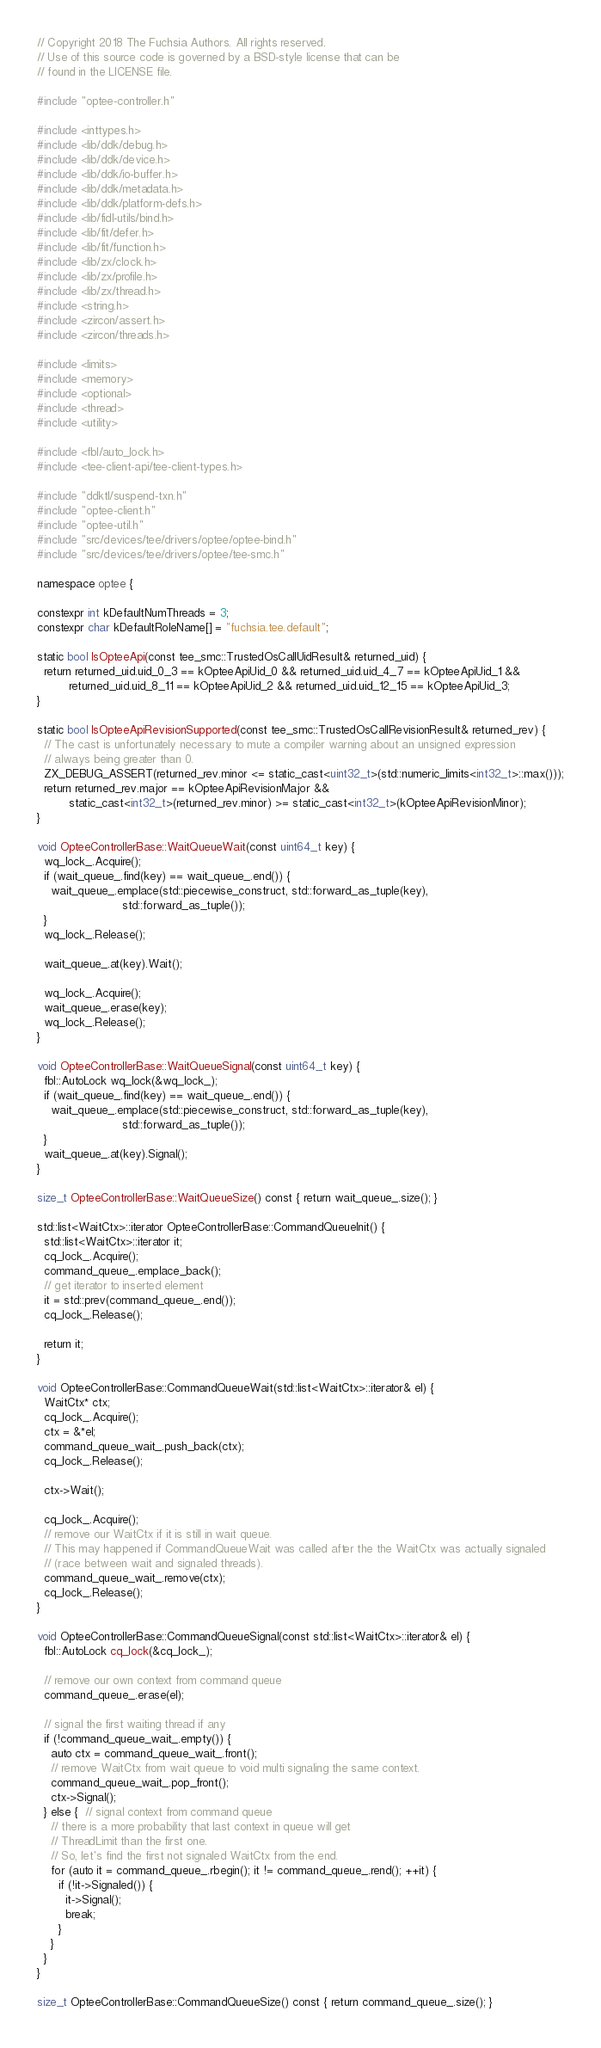<code> <loc_0><loc_0><loc_500><loc_500><_C++_>// Copyright 2018 The Fuchsia Authors. All rights reserved.
// Use of this source code is governed by a BSD-style license that can be
// found in the LICENSE file.

#include "optee-controller.h"

#include <inttypes.h>
#include <lib/ddk/debug.h>
#include <lib/ddk/device.h>
#include <lib/ddk/io-buffer.h>
#include <lib/ddk/metadata.h>
#include <lib/ddk/platform-defs.h>
#include <lib/fidl-utils/bind.h>
#include <lib/fit/defer.h>
#include <lib/fit/function.h>
#include <lib/zx/clock.h>
#include <lib/zx/profile.h>
#include <lib/zx/thread.h>
#include <string.h>
#include <zircon/assert.h>
#include <zircon/threads.h>

#include <limits>
#include <memory>
#include <optional>
#include <thread>
#include <utility>

#include <fbl/auto_lock.h>
#include <tee-client-api/tee-client-types.h>

#include "ddktl/suspend-txn.h"
#include "optee-client.h"
#include "optee-util.h"
#include "src/devices/tee/drivers/optee/optee-bind.h"
#include "src/devices/tee/drivers/optee/tee-smc.h"

namespace optee {

constexpr int kDefaultNumThreads = 3;
constexpr char kDefaultRoleName[] = "fuchsia.tee.default";

static bool IsOpteeApi(const tee_smc::TrustedOsCallUidResult& returned_uid) {
  return returned_uid.uid_0_3 == kOpteeApiUid_0 && returned_uid.uid_4_7 == kOpteeApiUid_1 &&
         returned_uid.uid_8_11 == kOpteeApiUid_2 && returned_uid.uid_12_15 == kOpteeApiUid_3;
}

static bool IsOpteeApiRevisionSupported(const tee_smc::TrustedOsCallRevisionResult& returned_rev) {
  // The cast is unfortunately necessary to mute a compiler warning about an unsigned expression
  // always being greater than 0.
  ZX_DEBUG_ASSERT(returned_rev.minor <= static_cast<uint32_t>(std::numeric_limits<int32_t>::max()));
  return returned_rev.major == kOpteeApiRevisionMajor &&
         static_cast<int32_t>(returned_rev.minor) >= static_cast<int32_t>(kOpteeApiRevisionMinor);
}

void OpteeControllerBase::WaitQueueWait(const uint64_t key) {
  wq_lock_.Acquire();
  if (wait_queue_.find(key) == wait_queue_.end()) {
    wait_queue_.emplace(std::piecewise_construct, std::forward_as_tuple(key),
                        std::forward_as_tuple());
  }
  wq_lock_.Release();

  wait_queue_.at(key).Wait();

  wq_lock_.Acquire();
  wait_queue_.erase(key);
  wq_lock_.Release();
}

void OpteeControllerBase::WaitQueueSignal(const uint64_t key) {
  fbl::AutoLock wq_lock(&wq_lock_);
  if (wait_queue_.find(key) == wait_queue_.end()) {
    wait_queue_.emplace(std::piecewise_construct, std::forward_as_tuple(key),
                        std::forward_as_tuple());
  }
  wait_queue_.at(key).Signal();
}

size_t OpteeControllerBase::WaitQueueSize() const { return wait_queue_.size(); }

std::list<WaitCtx>::iterator OpteeControllerBase::CommandQueueInit() {
  std::list<WaitCtx>::iterator it;
  cq_lock_.Acquire();
  command_queue_.emplace_back();
  // get iterator to inserted element
  it = std::prev(command_queue_.end());
  cq_lock_.Release();

  return it;
}

void OpteeControllerBase::CommandQueueWait(std::list<WaitCtx>::iterator& el) {
  WaitCtx* ctx;
  cq_lock_.Acquire();
  ctx = &*el;
  command_queue_wait_.push_back(ctx);
  cq_lock_.Release();

  ctx->Wait();

  cq_lock_.Acquire();
  // remove our WaitCtx if it is still in wait queue.
  // This may happened if CommandQueueWait was called after the the WaitCtx was actually signaled
  // (race between wait and signaled threads).
  command_queue_wait_.remove(ctx);
  cq_lock_.Release();
}

void OpteeControllerBase::CommandQueueSignal(const std::list<WaitCtx>::iterator& el) {
  fbl::AutoLock cq_lock(&cq_lock_);

  // remove our own context from command queue
  command_queue_.erase(el);

  // signal the first waiting thread if any
  if (!command_queue_wait_.empty()) {
    auto ctx = command_queue_wait_.front();
    // remove WaitCtx from wait queue to void multi signaling the same context.
    command_queue_wait_.pop_front();
    ctx->Signal();
  } else {  // signal context from command queue
    // there is a more probability that last context in queue will get
    // ThreadLimit than the first one.
    // So, let's find the first not signaled WaitCtx from the end.
    for (auto it = command_queue_.rbegin(); it != command_queue_.rend(); ++it) {
      if (!it->Signaled()) {
        it->Signal();
        break;
      }
    }
  }
}

size_t OpteeControllerBase::CommandQueueSize() const { return command_queue_.size(); }</code> 